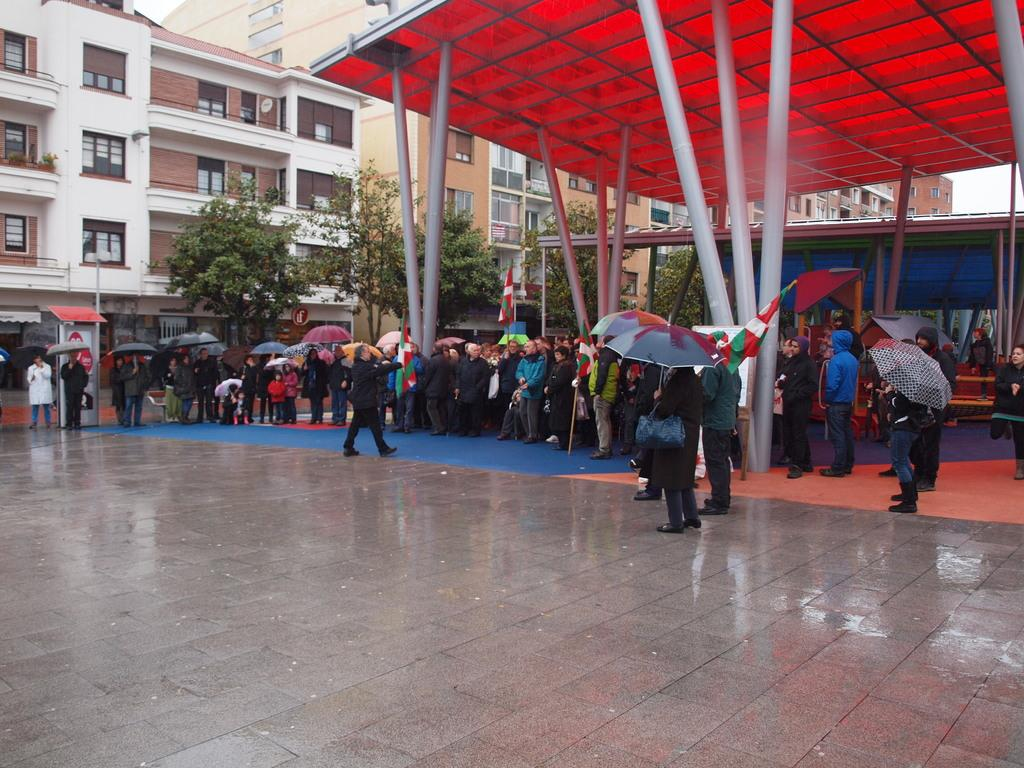How many people are in the image? There is a group of people in the image, but the exact number is not specified. What are some people doing in the image? Some people are holding umbrellas in the image. What can be seen in the background of the image? Buildings, windows, trees, poles, and a shed are visible in the background of the image. What is the color of the sky in the image? The sky appears to be white in color in the image. What type of winter sport is being played in the image? There is no indication of any winter sport being played in the image, as it does not depict any such activity. 